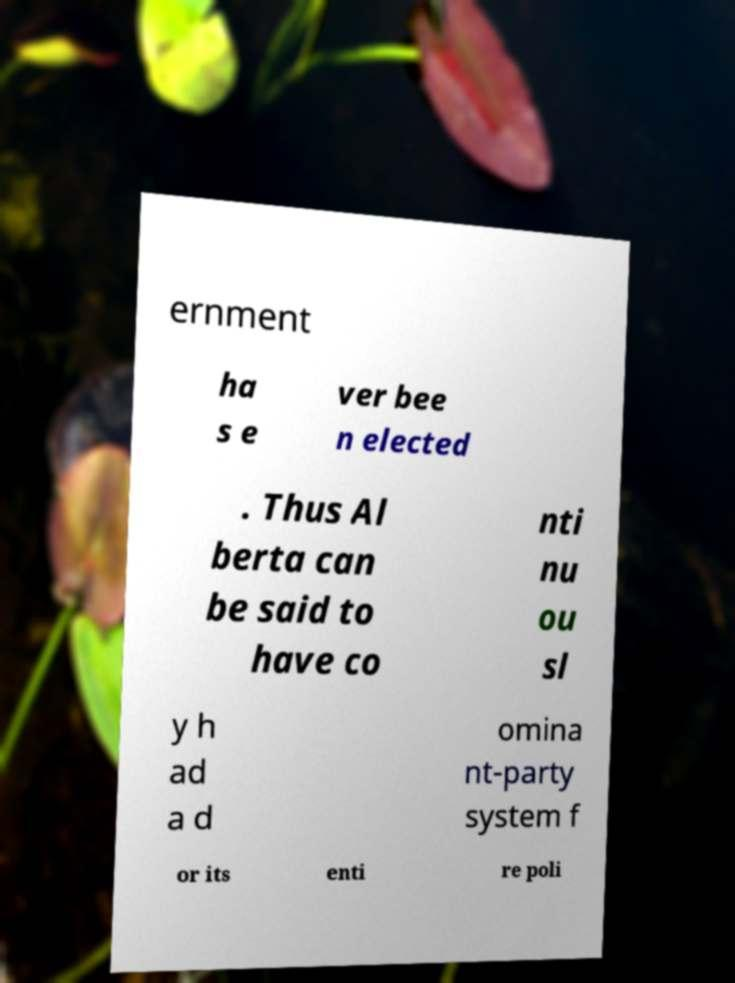Can you read and provide the text displayed in the image?This photo seems to have some interesting text. Can you extract and type it out for me? ernment ha s e ver bee n elected . Thus Al berta can be said to have co nti nu ou sl y h ad a d omina nt-party system f or its enti re poli 